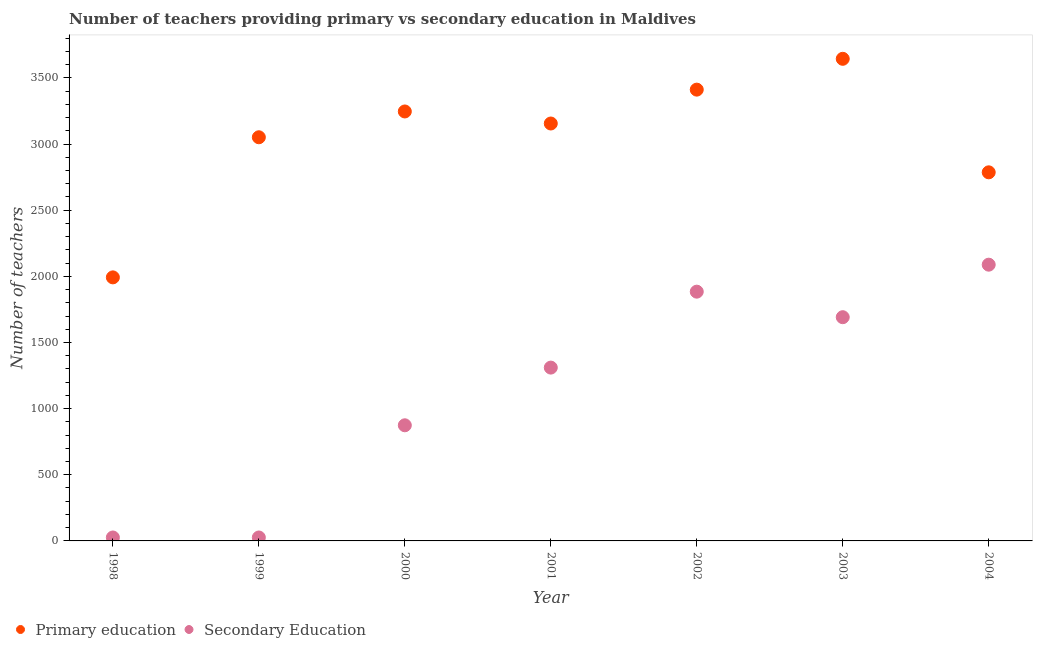How many different coloured dotlines are there?
Offer a very short reply. 2. Is the number of dotlines equal to the number of legend labels?
Your answer should be very brief. Yes. What is the number of secondary teachers in 2000?
Provide a short and direct response. 874. Across all years, what is the maximum number of primary teachers?
Provide a short and direct response. 3644. In which year was the number of primary teachers maximum?
Your response must be concise. 2003. What is the total number of primary teachers in the graph?
Your answer should be very brief. 2.13e+04. What is the difference between the number of primary teachers in 2001 and that in 2003?
Offer a terse response. -489. What is the difference between the number of secondary teachers in 1999 and the number of primary teachers in 2002?
Give a very brief answer. -3385. What is the average number of primary teachers per year?
Provide a succinct answer. 3040.71. In the year 2003, what is the difference between the number of primary teachers and number of secondary teachers?
Offer a very short reply. 1953. In how many years, is the number of primary teachers greater than 3000?
Your answer should be very brief. 5. What is the ratio of the number of primary teachers in 1998 to that in 2000?
Your answer should be very brief. 0.61. Is the number of primary teachers in 1999 less than that in 2002?
Offer a terse response. Yes. What is the difference between the highest and the second highest number of primary teachers?
Ensure brevity in your answer.  233. What is the difference between the highest and the lowest number of primary teachers?
Your answer should be compact. 1652. In how many years, is the number of primary teachers greater than the average number of primary teachers taken over all years?
Ensure brevity in your answer.  5. How many dotlines are there?
Ensure brevity in your answer.  2. What is the difference between two consecutive major ticks on the Y-axis?
Provide a succinct answer. 500. Are the values on the major ticks of Y-axis written in scientific E-notation?
Give a very brief answer. No. Does the graph contain grids?
Give a very brief answer. No. Where does the legend appear in the graph?
Provide a short and direct response. Bottom left. How many legend labels are there?
Make the answer very short. 2. What is the title of the graph?
Give a very brief answer. Number of teachers providing primary vs secondary education in Maldives. What is the label or title of the X-axis?
Make the answer very short. Year. What is the label or title of the Y-axis?
Keep it short and to the point. Number of teachers. What is the Number of teachers in Primary education in 1998?
Your answer should be very brief. 1992. What is the Number of teachers in Primary education in 1999?
Keep it short and to the point. 3051. What is the Number of teachers in Primary education in 2000?
Provide a short and direct response. 3246. What is the Number of teachers in Secondary Education in 2000?
Keep it short and to the point. 874. What is the Number of teachers of Primary education in 2001?
Your response must be concise. 3155. What is the Number of teachers of Secondary Education in 2001?
Offer a terse response. 1310. What is the Number of teachers in Primary education in 2002?
Provide a short and direct response. 3411. What is the Number of teachers of Secondary Education in 2002?
Provide a succinct answer. 1884. What is the Number of teachers of Primary education in 2003?
Your answer should be compact. 3644. What is the Number of teachers of Secondary Education in 2003?
Offer a very short reply. 1691. What is the Number of teachers in Primary education in 2004?
Offer a terse response. 2786. What is the Number of teachers of Secondary Education in 2004?
Offer a terse response. 2088. Across all years, what is the maximum Number of teachers of Primary education?
Provide a succinct answer. 3644. Across all years, what is the maximum Number of teachers in Secondary Education?
Your answer should be very brief. 2088. Across all years, what is the minimum Number of teachers of Primary education?
Give a very brief answer. 1992. Across all years, what is the minimum Number of teachers in Secondary Education?
Your answer should be compact. 26. What is the total Number of teachers in Primary education in the graph?
Your response must be concise. 2.13e+04. What is the total Number of teachers of Secondary Education in the graph?
Make the answer very short. 7899. What is the difference between the Number of teachers of Primary education in 1998 and that in 1999?
Offer a very short reply. -1059. What is the difference between the Number of teachers in Secondary Education in 1998 and that in 1999?
Your answer should be compact. 0. What is the difference between the Number of teachers in Primary education in 1998 and that in 2000?
Your response must be concise. -1254. What is the difference between the Number of teachers of Secondary Education in 1998 and that in 2000?
Ensure brevity in your answer.  -848. What is the difference between the Number of teachers of Primary education in 1998 and that in 2001?
Provide a succinct answer. -1163. What is the difference between the Number of teachers of Secondary Education in 1998 and that in 2001?
Your response must be concise. -1284. What is the difference between the Number of teachers in Primary education in 1998 and that in 2002?
Provide a succinct answer. -1419. What is the difference between the Number of teachers of Secondary Education in 1998 and that in 2002?
Provide a short and direct response. -1858. What is the difference between the Number of teachers in Primary education in 1998 and that in 2003?
Make the answer very short. -1652. What is the difference between the Number of teachers of Secondary Education in 1998 and that in 2003?
Provide a short and direct response. -1665. What is the difference between the Number of teachers of Primary education in 1998 and that in 2004?
Offer a terse response. -794. What is the difference between the Number of teachers of Secondary Education in 1998 and that in 2004?
Offer a very short reply. -2062. What is the difference between the Number of teachers in Primary education in 1999 and that in 2000?
Provide a short and direct response. -195. What is the difference between the Number of teachers in Secondary Education in 1999 and that in 2000?
Make the answer very short. -848. What is the difference between the Number of teachers in Primary education in 1999 and that in 2001?
Offer a very short reply. -104. What is the difference between the Number of teachers of Secondary Education in 1999 and that in 2001?
Make the answer very short. -1284. What is the difference between the Number of teachers in Primary education in 1999 and that in 2002?
Your answer should be very brief. -360. What is the difference between the Number of teachers in Secondary Education in 1999 and that in 2002?
Make the answer very short. -1858. What is the difference between the Number of teachers of Primary education in 1999 and that in 2003?
Keep it short and to the point. -593. What is the difference between the Number of teachers of Secondary Education in 1999 and that in 2003?
Provide a succinct answer. -1665. What is the difference between the Number of teachers in Primary education in 1999 and that in 2004?
Ensure brevity in your answer.  265. What is the difference between the Number of teachers of Secondary Education in 1999 and that in 2004?
Your answer should be compact. -2062. What is the difference between the Number of teachers of Primary education in 2000 and that in 2001?
Provide a succinct answer. 91. What is the difference between the Number of teachers of Secondary Education in 2000 and that in 2001?
Provide a succinct answer. -436. What is the difference between the Number of teachers of Primary education in 2000 and that in 2002?
Provide a succinct answer. -165. What is the difference between the Number of teachers of Secondary Education in 2000 and that in 2002?
Offer a terse response. -1010. What is the difference between the Number of teachers of Primary education in 2000 and that in 2003?
Keep it short and to the point. -398. What is the difference between the Number of teachers in Secondary Education in 2000 and that in 2003?
Offer a very short reply. -817. What is the difference between the Number of teachers of Primary education in 2000 and that in 2004?
Keep it short and to the point. 460. What is the difference between the Number of teachers of Secondary Education in 2000 and that in 2004?
Make the answer very short. -1214. What is the difference between the Number of teachers of Primary education in 2001 and that in 2002?
Your answer should be very brief. -256. What is the difference between the Number of teachers of Secondary Education in 2001 and that in 2002?
Provide a succinct answer. -574. What is the difference between the Number of teachers in Primary education in 2001 and that in 2003?
Provide a succinct answer. -489. What is the difference between the Number of teachers of Secondary Education in 2001 and that in 2003?
Offer a terse response. -381. What is the difference between the Number of teachers of Primary education in 2001 and that in 2004?
Keep it short and to the point. 369. What is the difference between the Number of teachers in Secondary Education in 2001 and that in 2004?
Provide a short and direct response. -778. What is the difference between the Number of teachers in Primary education in 2002 and that in 2003?
Ensure brevity in your answer.  -233. What is the difference between the Number of teachers in Secondary Education in 2002 and that in 2003?
Offer a terse response. 193. What is the difference between the Number of teachers in Primary education in 2002 and that in 2004?
Provide a succinct answer. 625. What is the difference between the Number of teachers of Secondary Education in 2002 and that in 2004?
Ensure brevity in your answer.  -204. What is the difference between the Number of teachers in Primary education in 2003 and that in 2004?
Your answer should be very brief. 858. What is the difference between the Number of teachers in Secondary Education in 2003 and that in 2004?
Provide a succinct answer. -397. What is the difference between the Number of teachers in Primary education in 1998 and the Number of teachers in Secondary Education in 1999?
Make the answer very short. 1966. What is the difference between the Number of teachers of Primary education in 1998 and the Number of teachers of Secondary Education in 2000?
Provide a succinct answer. 1118. What is the difference between the Number of teachers of Primary education in 1998 and the Number of teachers of Secondary Education in 2001?
Provide a short and direct response. 682. What is the difference between the Number of teachers in Primary education in 1998 and the Number of teachers in Secondary Education in 2002?
Make the answer very short. 108. What is the difference between the Number of teachers in Primary education in 1998 and the Number of teachers in Secondary Education in 2003?
Keep it short and to the point. 301. What is the difference between the Number of teachers of Primary education in 1998 and the Number of teachers of Secondary Education in 2004?
Your answer should be very brief. -96. What is the difference between the Number of teachers of Primary education in 1999 and the Number of teachers of Secondary Education in 2000?
Make the answer very short. 2177. What is the difference between the Number of teachers in Primary education in 1999 and the Number of teachers in Secondary Education in 2001?
Offer a very short reply. 1741. What is the difference between the Number of teachers in Primary education in 1999 and the Number of teachers in Secondary Education in 2002?
Make the answer very short. 1167. What is the difference between the Number of teachers in Primary education in 1999 and the Number of teachers in Secondary Education in 2003?
Keep it short and to the point. 1360. What is the difference between the Number of teachers in Primary education in 1999 and the Number of teachers in Secondary Education in 2004?
Ensure brevity in your answer.  963. What is the difference between the Number of teachers of Primary education in 2000 and the Number of teachers of Secondary Education in 2001?
Your answer should be very brief. 1936. What is the difference between the Number of teachers of Primary education in 2000 and the Number of teachers of Secondary Education in 2002?
Your answer should be very brief. 1362. What is the difference between the Number of teachers in Primary education in 2000 and the Number of teachers in Secondary Education in 2003?
Give a very brief answer. 1555. What is the difference between the Number of teachers in Primary education in 2000 and the Number of teachers in Secondary Education in 2004?
Provide a short and direct response. 1158. What is the difference between the Number of teachers of Primary education in 2001 and the Number of teachers of Secondary Education in 2002?
Your response must be concise. 1271. What is the difference between the Number of teachers of Primary education in 2001 and the Number of teachers of Secondary Education in 2003?
Offer a terse response. 1464. What is the difference between the Number of teachers in Primary education in 2001 and the Number of teachers in Secondary Education in 2004?
Your answer should be very brief. 1067. What is the difference between the Number of teachers of Primary education in 2002 and the Number of teachers of Secondary Education in 2003?
Provide a succinct answer. 1720. What is the difference between the Number of teachers of Primary education in 2002 and the Number of teachers of Secondary Education in 2004?
Provide a short and direct response. 1323. What is the difference between the Number of teachers of Primary education in 2003 and the Number of teachers of Secondary Education in 2004?
Your answer should be very brief. 1556. What is the average Number of teachers of Primary education per year?
Offer a terse response. 3040.71. What is the average Number of teachers in Secondary Education per year?
Your answer should be very brief. 1128.43. In the year 1998, what is the difference between the Number of teachers of Primary education and Number of teachers of Secondary Education?
Offer a terse response. 1966. In the year 1999, what is the difference between the Number of teachers of Primary education and Number of teachers of Secondary Education?
Make the answer very short. 3025. In the year 2000, what is the difference between the Number of teachers in Primary education and Number of teachers in Secondary Education?
Your answer should be compact. 2372. In the year 2001, what is the difference between the Number of teachers of Primary education and Number of teachers of Secondary Education?
Keep it short and to the point. 1845. In the year 2002, what is the difference between the Number of teachers in Primary education and Number of teachers in Secondary Education?
Give a very brief answer. 1527. In the year 2003, what is the difference between the Number of teachers in Primary education and Number of teachers in Secondary Education?
Offer a very short reply. 1953. In the year 2004, what is the difference between the Number of teachers in Primary education and Number of teachers in Secondary Education?
Keep it short and to the point. 698. What is the ratio of the Number of teachers of Primary education in 1998 to that in 1999?
Provide a succinct answer. 0.65. What is the ratio of the Number of teachers of Primary education in 1998 to that in 2000?
Ensure brevity in your answer.  0.61. What is the ratio of the Number of teachers of Secondary Education in 1998 to that in 2000?
Provide a succinct answer. 0.03. What is the ratio of the Number of teachers in Primary education in 1998 to that in 2001?
Keep it short and to the point. 0.63. What is the ratio of the Number of teachers of Secondary Education in 1998 to that in 2001?
Provide a succinct answer. 0.02. What is the ratio of the Number of teachers in Primary education in 1998 to that in 2002?
Keep it short and to the point. 0.58. What is the ratio of the Number of teachers in Secondary Education in 1998 to that in 2002?
Your answer should be very brief. 0.01. What is the ratio of the Number of teachers in Primary education in 1998 to that in 2003?
Your response must be concise. 0.55. What is the ratio of the Number of teachers in Secondary Education in 1998 to that in 2003?
Ensure brevity in your answer.  0.02. What is the ratio of the Number of teachers of Primary education in 1998 to that in 2004?
Keep it short and to the point. 0.71. What is the ratio of the Number of teachers of Secondary Education in 1998 to that in 2004?
Make the answer very short. 0.01. What is the ratio of the Number of teachers in Primary education in 1999 to that in 2000?
Ensure brevity in your answer.  0.94. What is the ratio of the Number of teachers of Secondary Education in 1999 to that in 2000?
Provide a short and direct response. 0.03. What is the ratio of the Number of teachers in Primary education in 1999 to that in 2001?
Offer a terse response. 0.97. What is the ratio of the Number of teachers in Secondary Education in 1999 to that in 2001?
Keep it short and to the point. 0.02. What is the ratio of the Number of teachers in Primary education in 1999 to that in 2002?
Offer a terse response. 0.89. What is the ratio of the Number of teachers in Secondary Education in 1999 to that in 2002?
Your response must be concise. 0.01. What is the ratio of the Number of teachers in Primary education in 1999 to that in 2003?
Your answer should be compact. 0.84. What is the ratio of the Number of teachers in Secondary Education in 1999 to that in 2003?
Offer a terse response. 0.02. What is the ratio of the Number of teachers of Primary education in 1999 to that in 2004?
Ensure brevity in your answer.  1.1. What is the ratio of the Number of teachers in Secondary Education in 1999 to that in 2004?
Give a very brief answer. 0.01. What is the ratio of the Number of teachers in Primary education in 2000 to that in 2001?
Your response must be concise. 1.03. What is the ratio of the Number of teachers of Secondary Education in 2000 to that in 2001?
Your response must be concise. 0.67. What is the ratio of the Number of teachers in Primary education in 2000 to that in 2002?
Offer a terse response. 0.95. What is the ratio of the Number of teachers of Secondary Education in 2000 to that in 2002?
Give a very brief answer. 0.46. What is the ratio of the Number of teachers in Primary education in 2000 to that in 2003?
Give a very brief answer. 0.89. What is the ratio of the Number of teachers of Secondary Education in 2000 to that in 2003?
Ensure brevity in your answer.  0.52. What is the ratio of the Number of teachers of Primary education in 2000 to that in 2004?
Your answer should be compact. 1.17. What is the ratio of the Number of teachers in Secondary Education in 2000 to that in 2004?
Make the answer very short. 0.42. What is the ratio of the Number of teachers in Primary education in 2001 to that in 2002?
Give a very brief answer. 0.92. What is the ratio of the Number of teachers in Secondary Education in 2001 to that in 2002?
Offer a terse response. 0.7. What is the ratio of the Number of teachers in Primary education in 2001 to that in 2003?
Offer a terse response. 0.87. What is the ratio of the Number of teachers in Secondary Education in 2001 to that in 2003?
Offer a terse response. 0.77. What is the ratio of the Number of teachers of Primary education in 2001 to that in 2004?
Keep it short and to the point. 1.13. What is the ratio of the Number of teachers in Secondary Education in 2001 to that in 2004?
Your answer should be compact. 0.63. What is the ratio of the Number of teachers in Primary education in 2002 to that in 2003?
Your answer should be very brief. 0.94. What is the ratio of the Number of teachers in Secondary Education in 2002 to that in 2003?
Offer a very short reply. 1.11. What is the ratio of the Number of teachers of Primary education in 2002 to that in 2004?
Ensure brevity in your answer.  1.22. What is the ratio of the Number of teachers of Secondary Education in 2002 to that in 2004?
Your answer should be very brief. 0.9. What is the ratio of the Number of teachers of Primary education in 2003 to that in 2004?
Your answer should be compact. 1.31. What is the ratio of the Number of teachers in Secondary Education in 2003 to that in 2004?
Provide a short and direct response. 0.81. What is the difference between the highest and the second highest Number of teachers in Primary education?
Ensure brevity in your answer.  233. What is the difference between the highest and the second highest Number of teachers of Secondary Education?
Make the answer very short. 204. What is the difference between the highest and the lowest Number of teachers of Primary education?
Your answer should be very brief. 1652. What is the difference between the highest and the lowest Number of teachers of Secondary Education?
Your answer should be compact. 2062. 